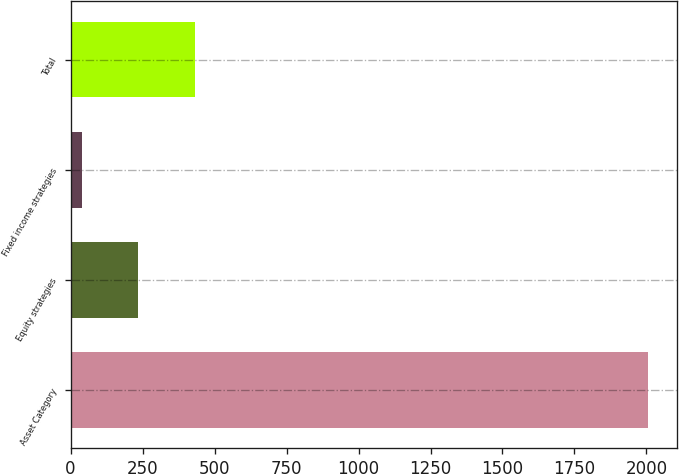Convert chart to OTSL. <chart><loc_0><loc_0><loc_500><loc_500><bar_chart><fcel>Asset Category<fcel>Equity strategies<fcel>Fixed income strategies<fcel>Total<nl><fcel>2007<fcel>234.9<fcel>38<fcel>431.8<nl></chart> 